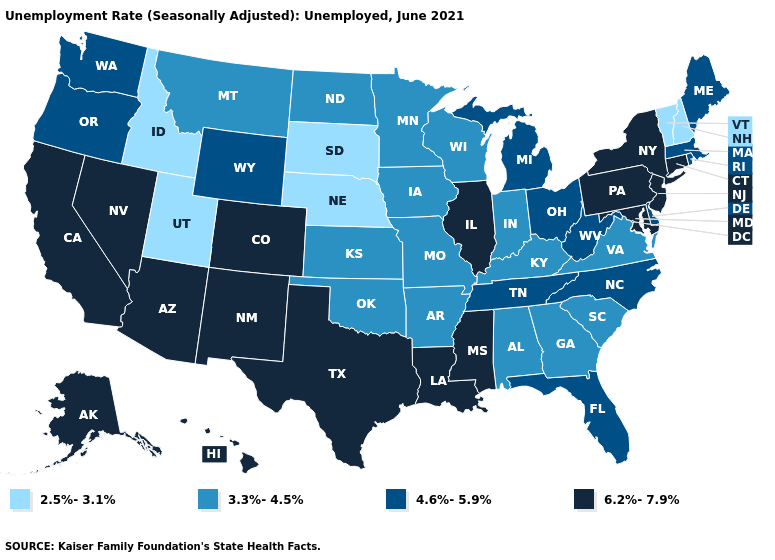What is the value of Texas?
Give a very brief answer. 6.2%-7.9%. What is the lowest value in the USA?
Concise answer only. 2.5%-3.1%. Which states hav the highest value in the South?
Answer briefly. Louisiana, Maryland, Mississippi, Texas. What is the value of Nebraska?
Concise answer only. 2.5%-3.1%. Which states have the lowest value in the MidWest?
Answer briefly. Nebraska, South Dakota. Does the first symbol in the legend represent the smallest category?
Keep it brief. Yes. Does Rhode Island have a higher value than Colorado?
Keep it brief. No. Which states have the lowest value in the USA?
Answer briefly. Idaho, Nebraska, New Hampshire, South Dakota, Utah, Vermont. Does New York have the lowest value in the Northeast?
Keep it brief. No. Does the map have missing data?
Write a very short answer. No. Does New Hampshire have the highest value in the Northeast?
Quick response, please. No. Name the states that have a value in the range 3.3%-4.5%?
Keep it brief. Alabama, Arkansas, Georgia, Indiana, Iowa, Kansas, Kentucky, Minnesota, Missouri, Montana, North Dakota, Oklahoma, South Carolina, Virginia, Wisconsin. What is the value of Kansas?
Give a very brief answer. 3.3%-4.5%. Name the states that have a value in the range 4.6%-5.9%?
Write a very short answer. Delaware, Florida, Maine, Massachusetts, Michigan, North Carolina, Ohio, Oregon, Rhode Island, Tennessee, Washington, West Virginia, Wyoming. 